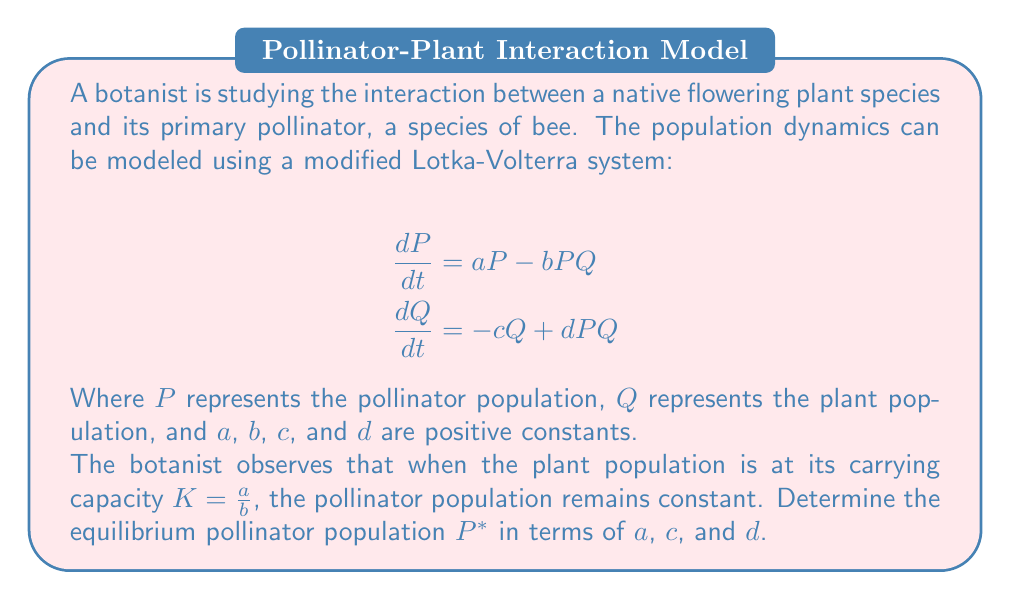Help me with this question. Let's approach this step-by-step:

1) At equilibrium, both $\frac{dP}{dt}$ and $\frac{dQ}{dt}$ should equal zero.

2) We're told that when the plant population is at its carrying capacity, $Q = K = \frac{a}{b}$, the pollinator population remains constant. This means $\frac{dP}{dt} = 0$ at this point.

3) Let's substitute these into the first equation:

   $$0 = aP^* - bP^*(\frac{a}{b})$$

4) Simplify:
   
   $$0 = aP^* - aP^* = 0$$

   This equation is always true for any $P^*$, so we need to use the second equation to find $P^*$.

5) Now, let's use the second equation, setting $\frac{dQ}{dt} = 0$ and $Q = \frac{a}{b}$:

   $$0 = -c(\frac{a}{b}) + dP^*(\frac{a}{b})$$

6) Multiply both sides by $b$:

   $$0 = -ca + dP^*a$$

7) Solve for $P^*$:

   $$dP^*a = ca$$
   $$P^* = \frac{c}{d}$$

Therefore, the equilibrium pollinator population $P^*$ is $\frac{c}{d}$.
Answer: $P^* = \frac{c}{d}$ 